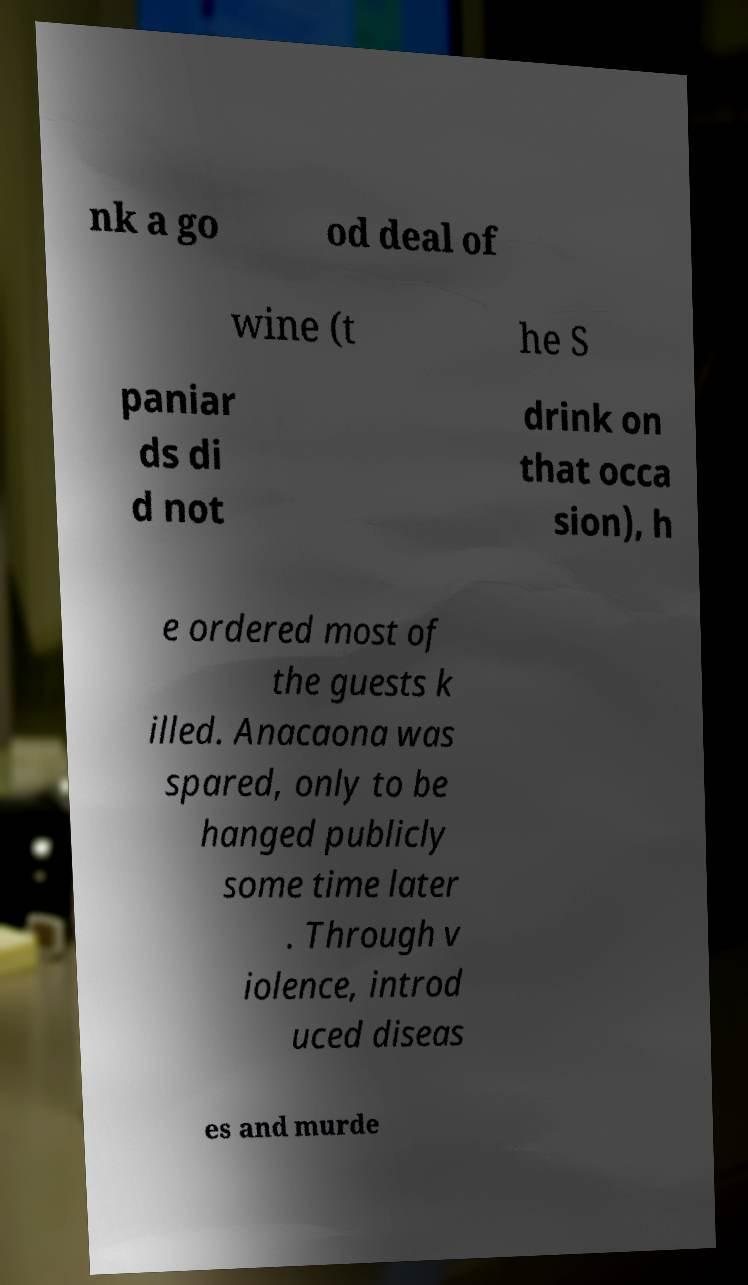Please read and relay the text visible in this image. What does it say? nk a go od deal of wine (t he S paniar ds di d not drink on that occa sion), h e ordered most of the guests k illed. Anacaona was spared, only to be hanged publicly some time later . Through v iolence, introd uced diseas es and murde 